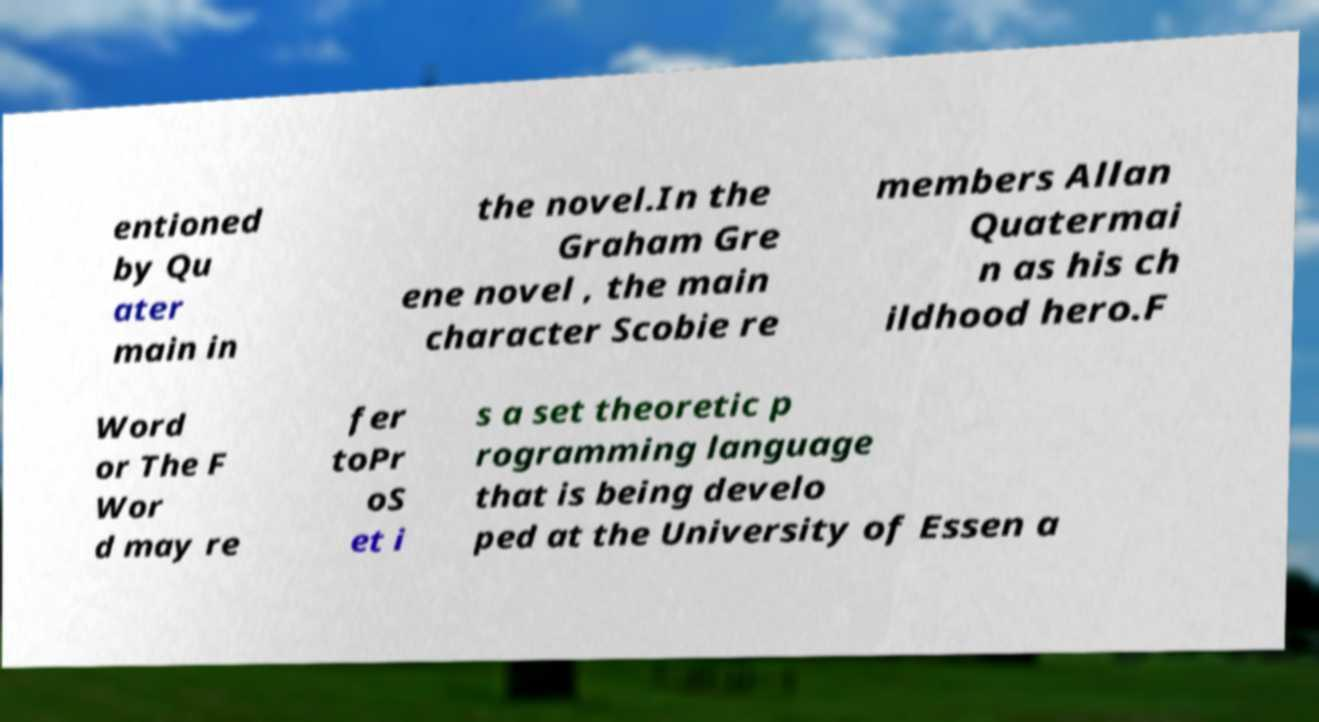There's text embedded in this image that I need extracted. Can you transcribe it verbatim? entioned by Qu ater main in the novel.In the Graham Gre ene novel , the main character Scobie re members Allan Quatermai n as his ch ildhood hero.F Word or The F Wor d may re fer toPr oS et i s a set theoretic p rogramming language that is being develo ped at the University of Essen a 